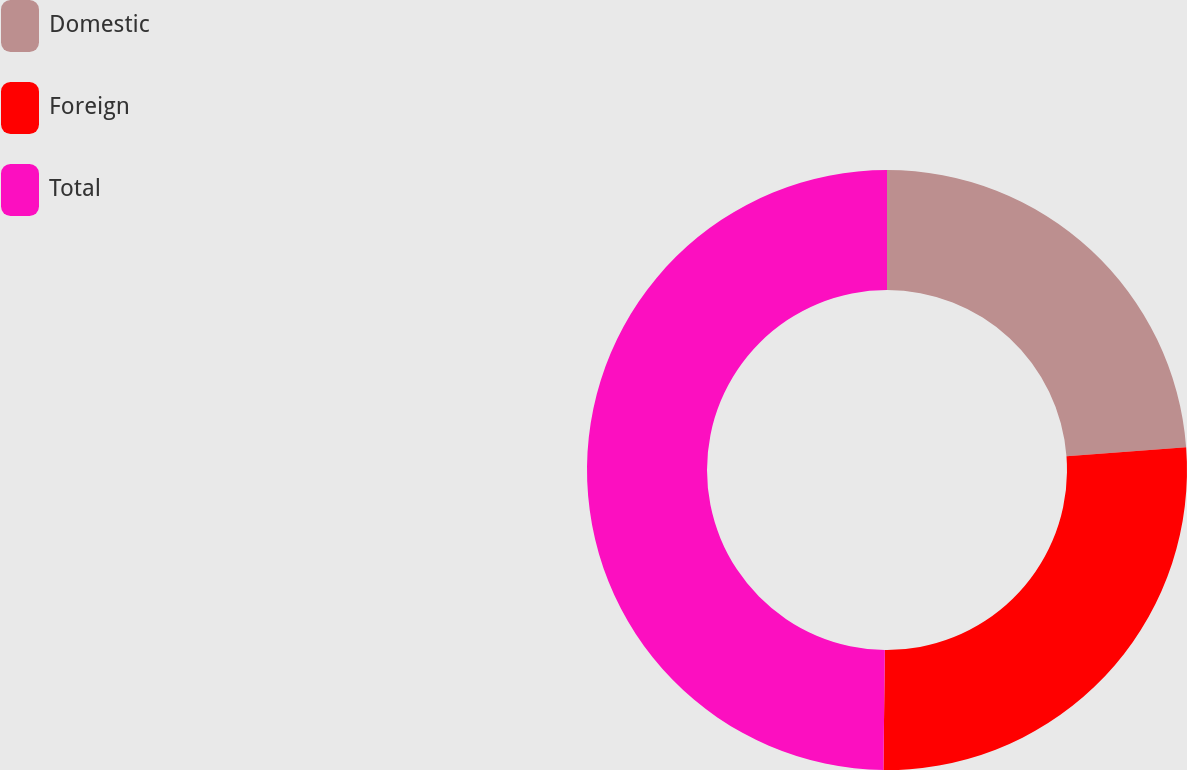Convert chart to OTSL. <chart><loc_0><loc_0><loc_500><loc_500><pie_chart><fcel>Domestic<fcel>Foreign<fcel>Total<nl><fcel>23.79%<fcel>26.4%<fcel>49.81%<nl></chart> 